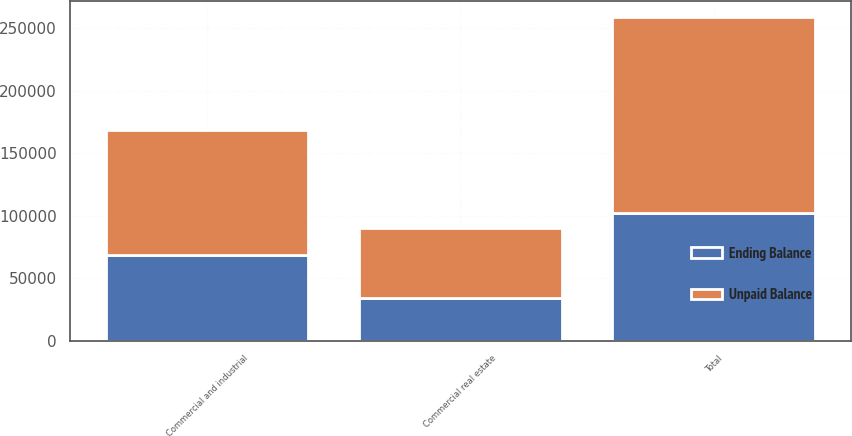Convert chart. <chart><loc_0><loc_0><loc_500><loc_500><stacked_bar_chart><ecel><fcel>Commercial and industrial<fcel>Commercial real estate<fcel>Total<nl><fcel>Ending Balance<fcel>68338<fcel>34042<fcel>102380<nl><fcel>Unpaid Balance<fcel>100031<fcel>56320<fcel>156351<nl></chart> 